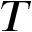<formula> <loc_0><loc_0><loc_500><loc_500>T</formula> 